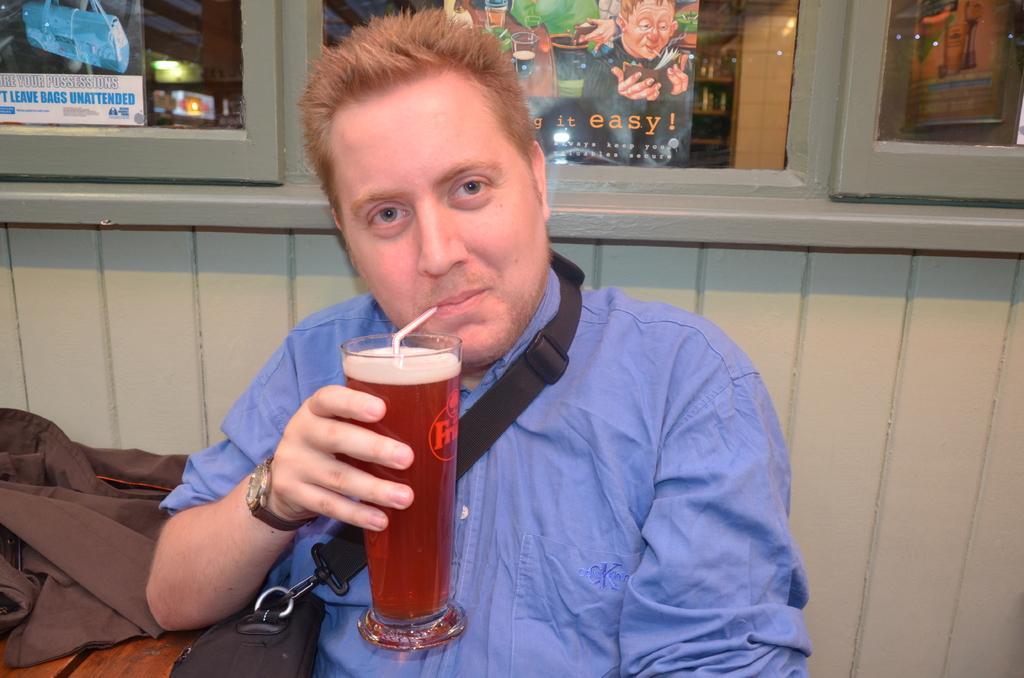Can you describe this image briefly? In this picture we can see a man is holding a glass with some liquid and in the glass there is a straw. On the left side of the man there is a cloth on a wooden object. Behind the man there is a wall with glass windows and on the windows there are posters. 